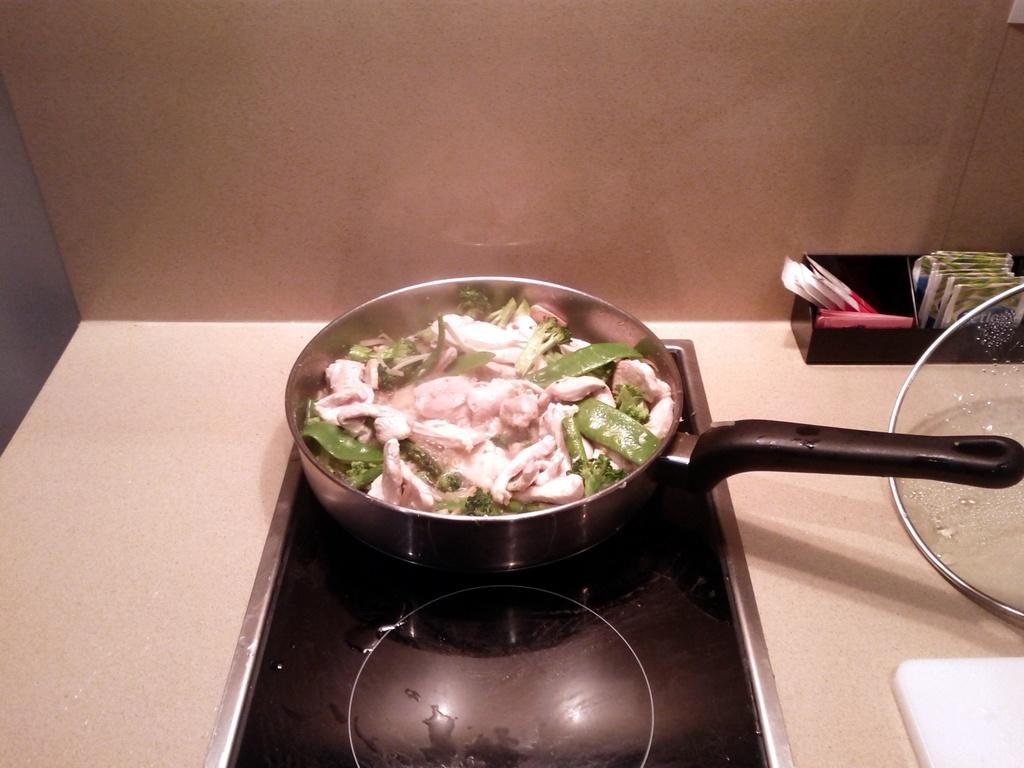Describe this image in one or two sentences. In this image I can see the cream and black colored surface and on it I can see a metal bowl with a food item which is cream and green in color. I can see the lid, a black colored object with few packets in it and the brown colored wall. 